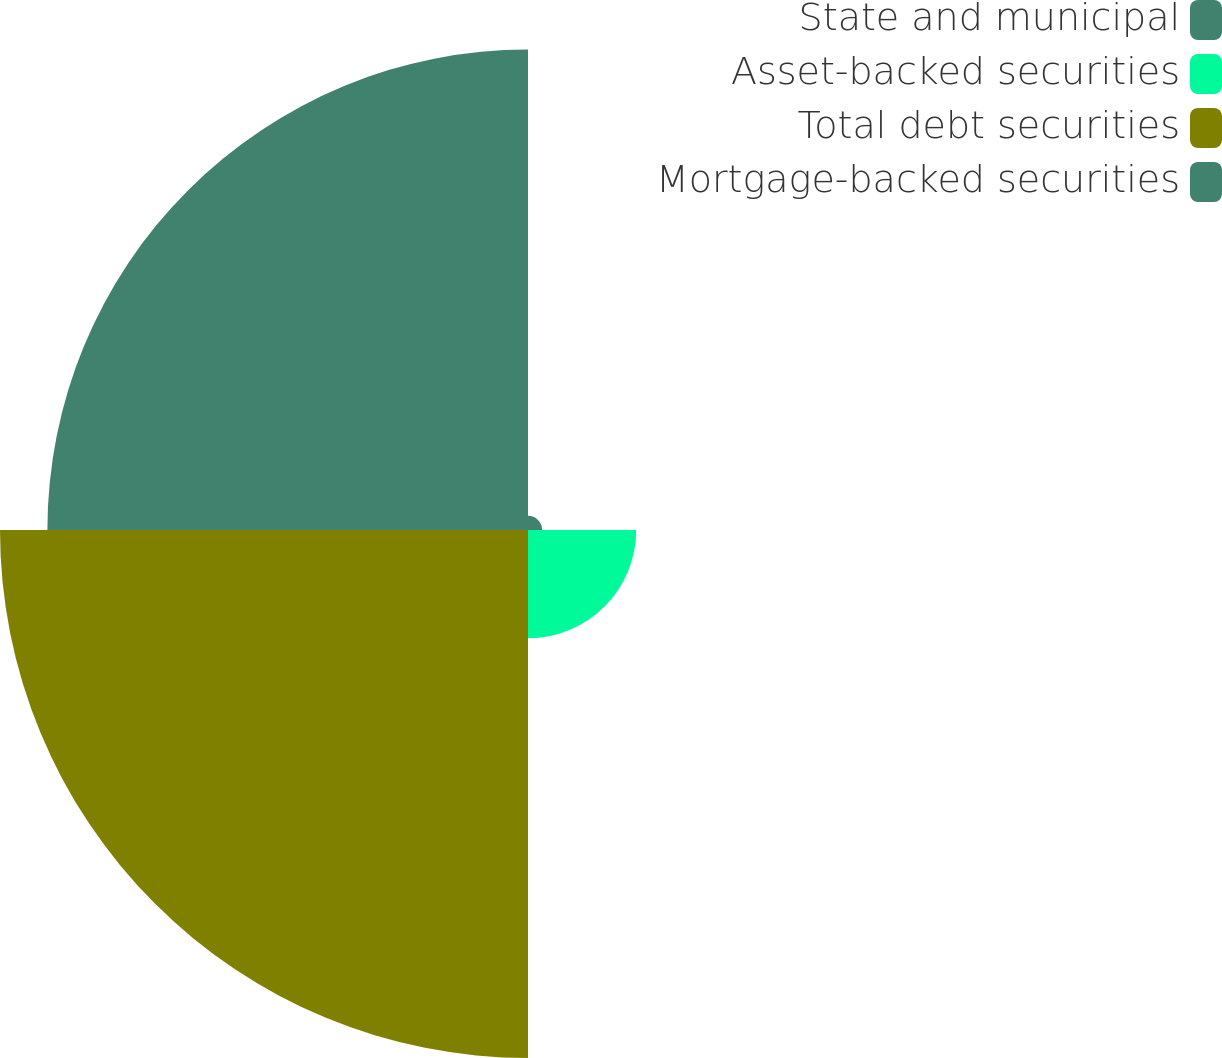Convert chart. <chart><loc_0><loc_0><loc_500><loc_500><pie_chart><fcel>State and municipal<fcel>Asset-backed securities<fcel>Total debt securities<fcel>Mortgage-backed securities<nl><fcel>1.25%<fcel>9.57%<fcel>46.68%<fcel>42.49%<nl></chart> 